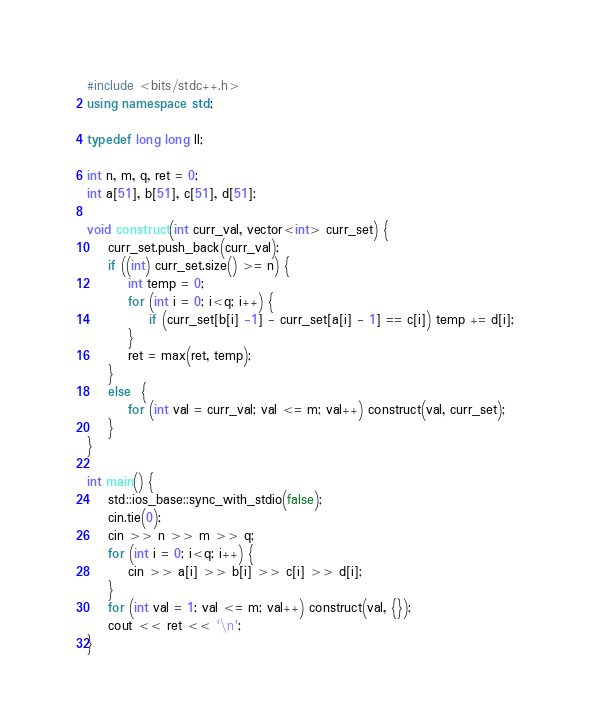<code> <loc_0><loc_0><loc_500><loc_500><_C++_>#include <bits/stdc++.h>
using namespace std;

typedef long long ll;

int n, m, q, ret = 0;
int a[51], b[51], c[51], d[51];

void construct(int curr_val, vector<int> curr_set) {
	curr_set.push_back(curr_val);
	if ((int) curr_set.size() >= n) {
		int temp = 0;
		for (int i = 0; i<q; i++) {
			if (curr_set[b[i] -1] - curr_set[a[i] - 1] == c[i]) temp += d[i];
		}
		ret = max(ret, temp);
	}
	else  {
		for (int val = curr_val; val <= m; val++) construct(val, curr_set);
	}
}

int main() {
	std::ios_base::sync_with_stdio(false);
	cin.tie(0);
	cin >> n >> m >> q;
	for (int i = 0; i<q; i++) {
		cin >> a[i] >> b[i] >> c[i] >> d[i];
	}
	for (int val = 1; val <= m; val++) construct(val, {});
	cout << ret << '\n';
}

</code> 